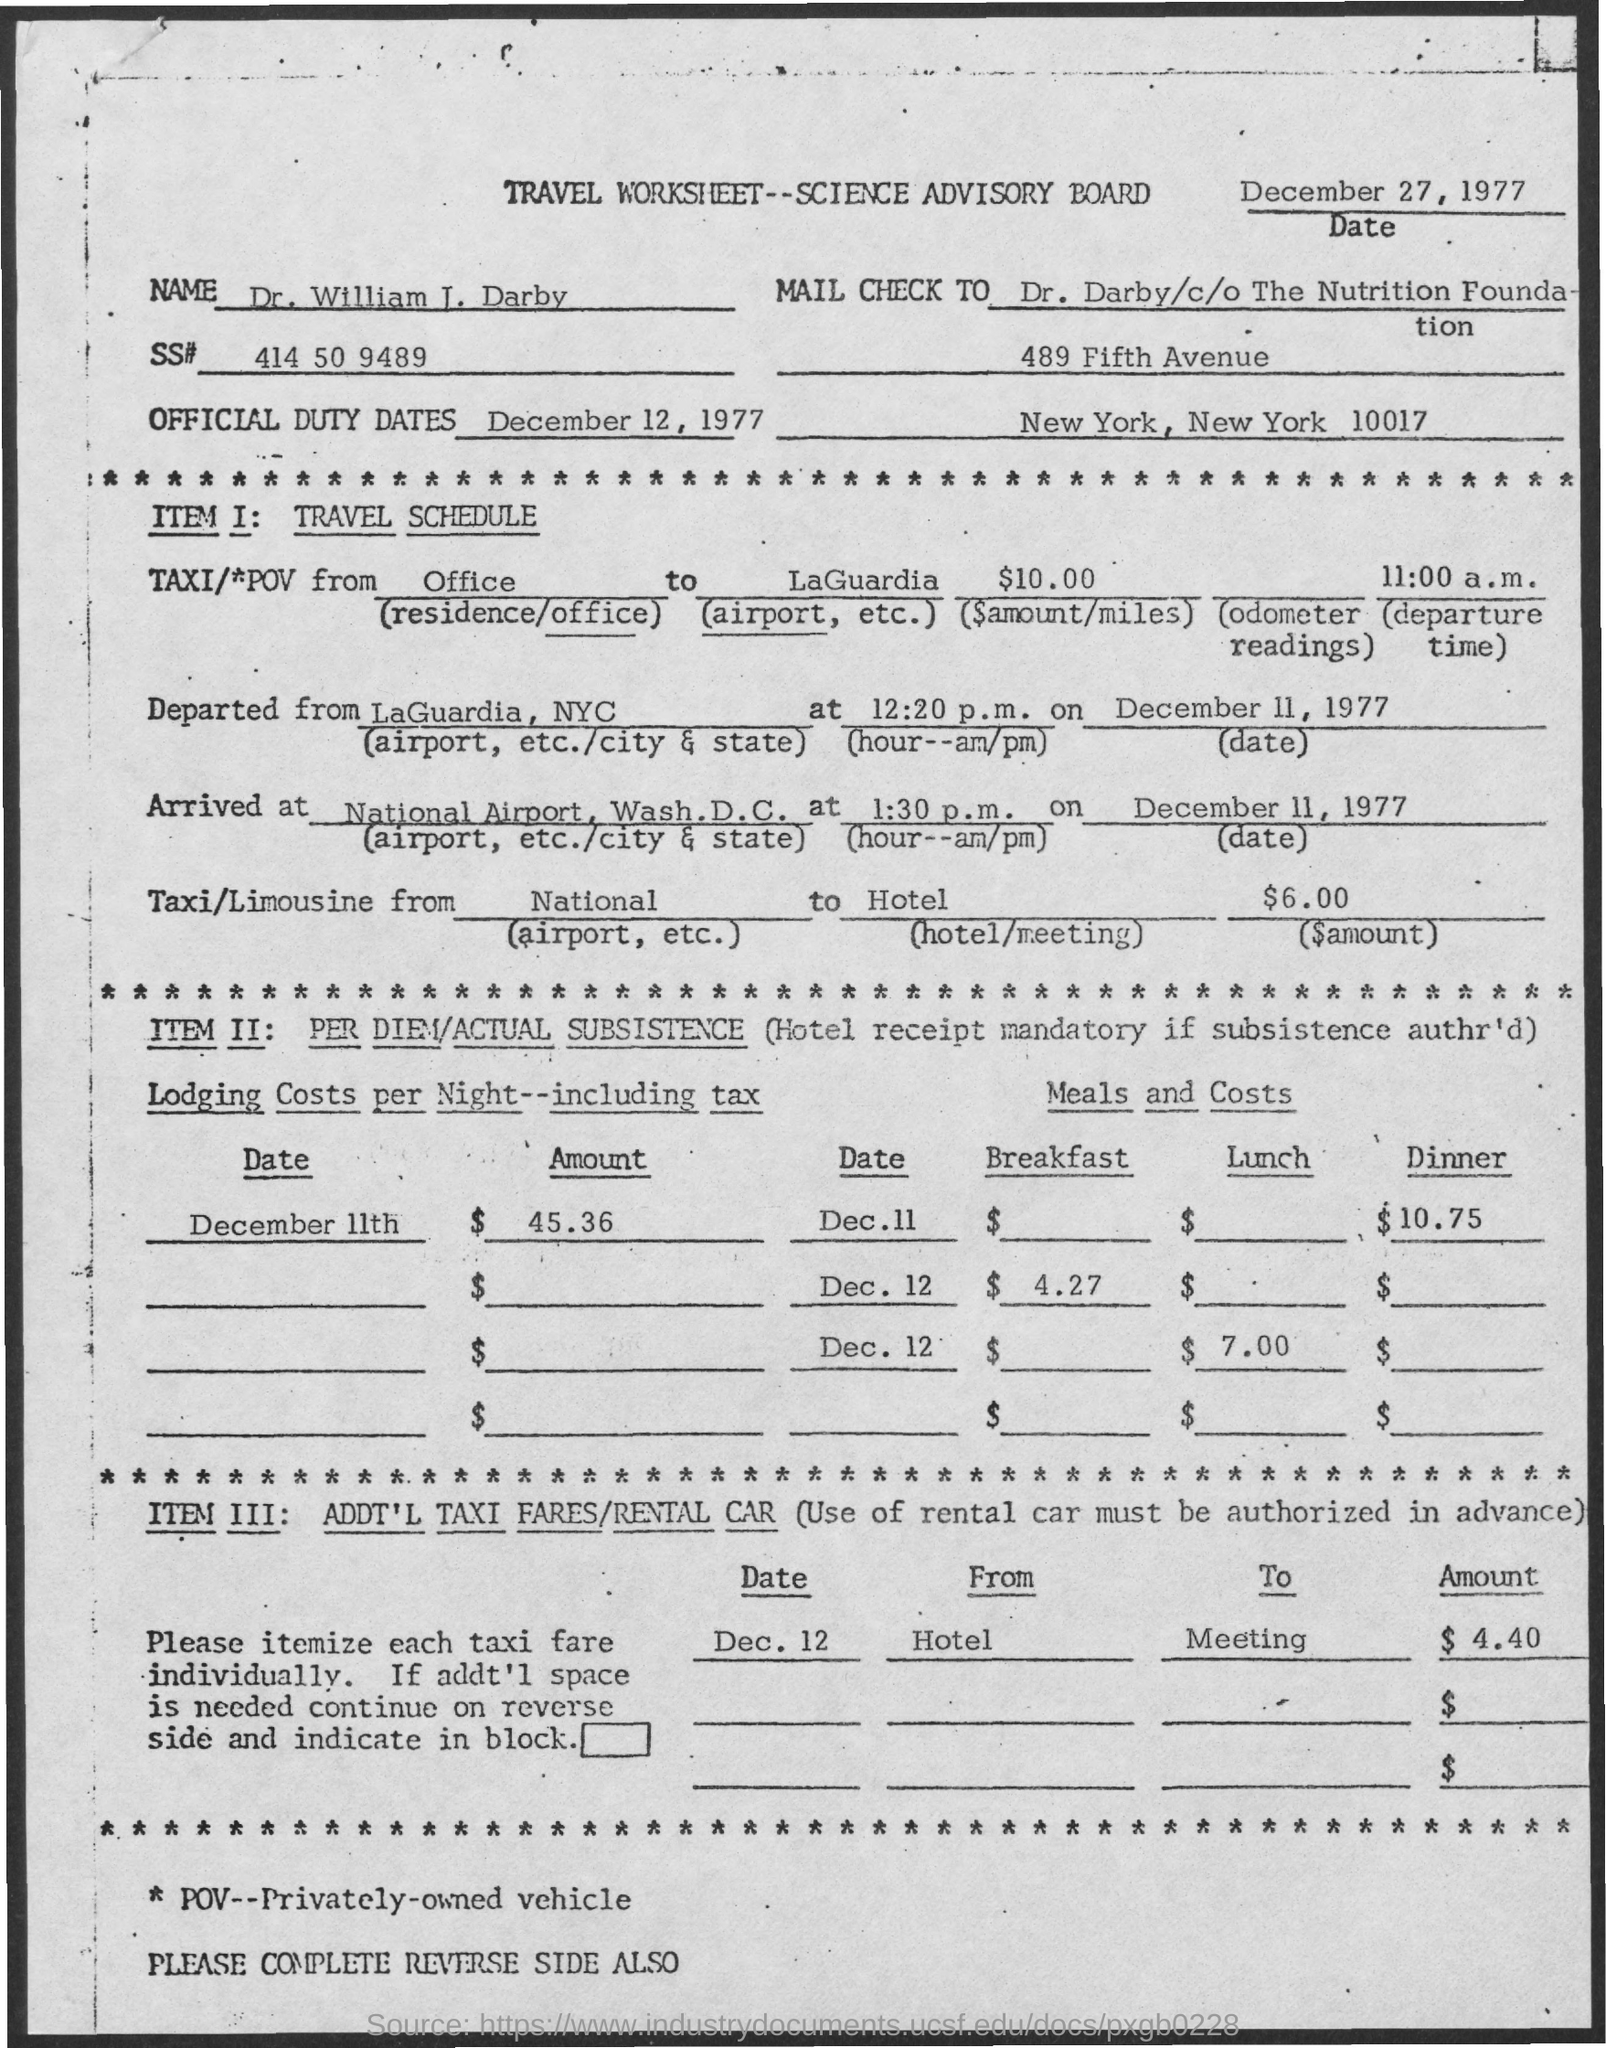Point out several critical features in this image. The full form of POV is "Privately-Owned Vehicle". The SS# number is 414 50 9489. 